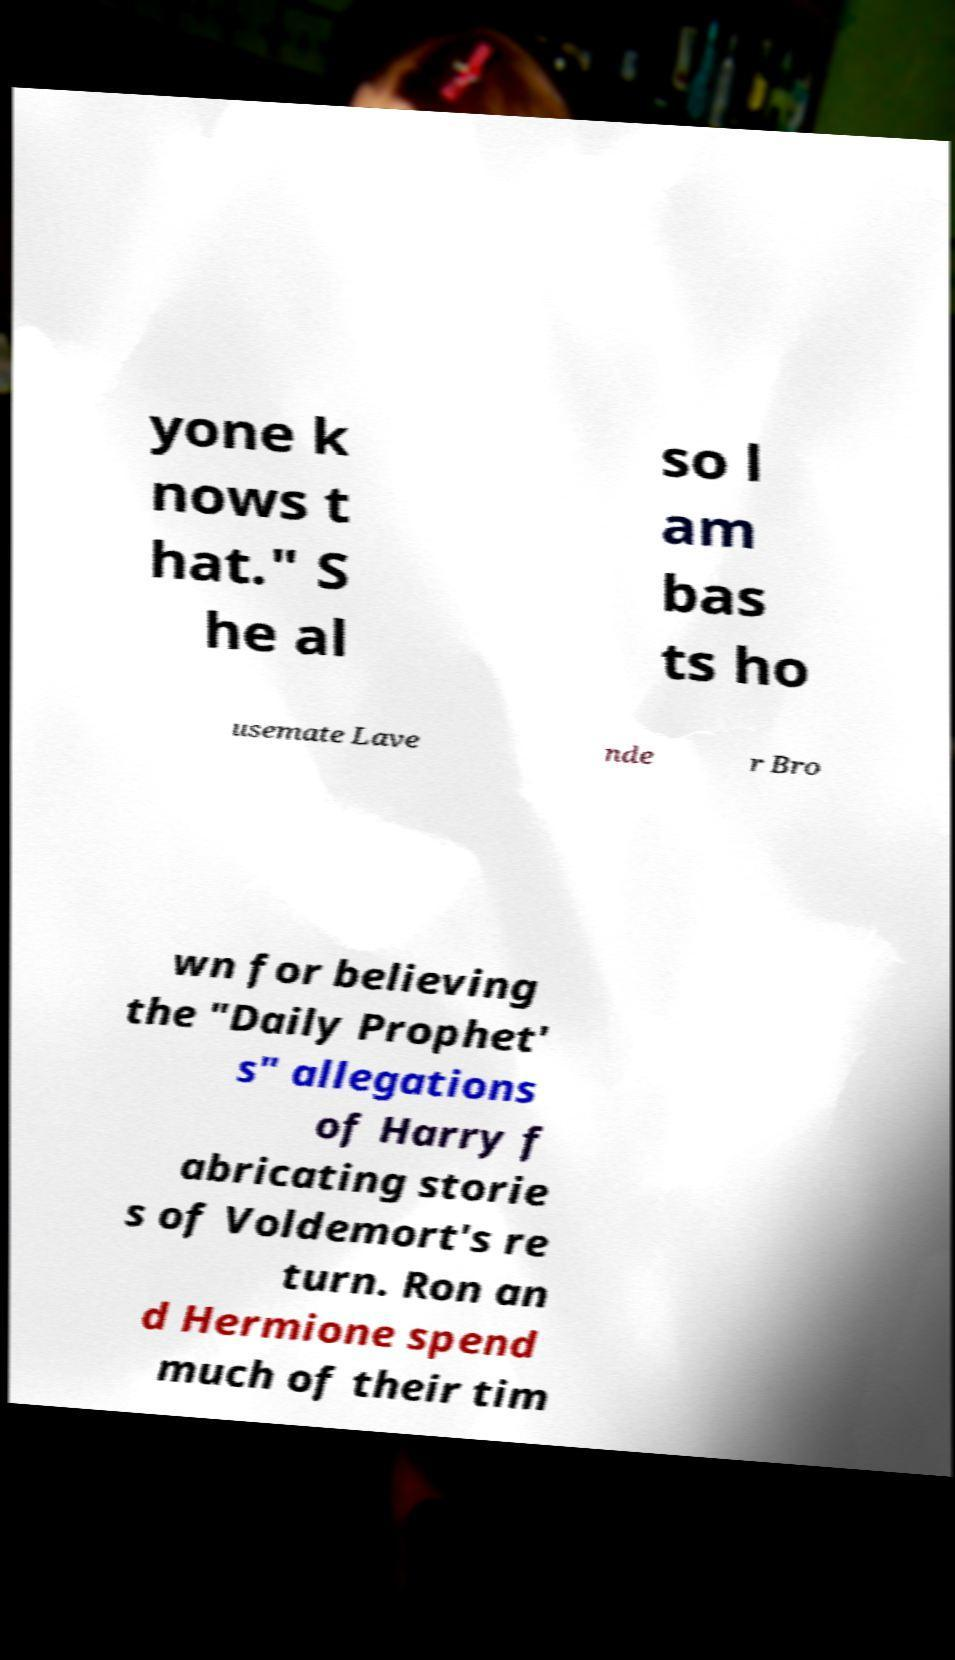Please identify and transcribe the text found in this image. yone k nows t hat." S he al so l am bas ts ho usemate Lave nde r Bro wn for believing the "Daily Prophet' s" allegations of Harry f abricating storie s of Voldemort's re turn. Ron an d Hermione spend much of their tim 